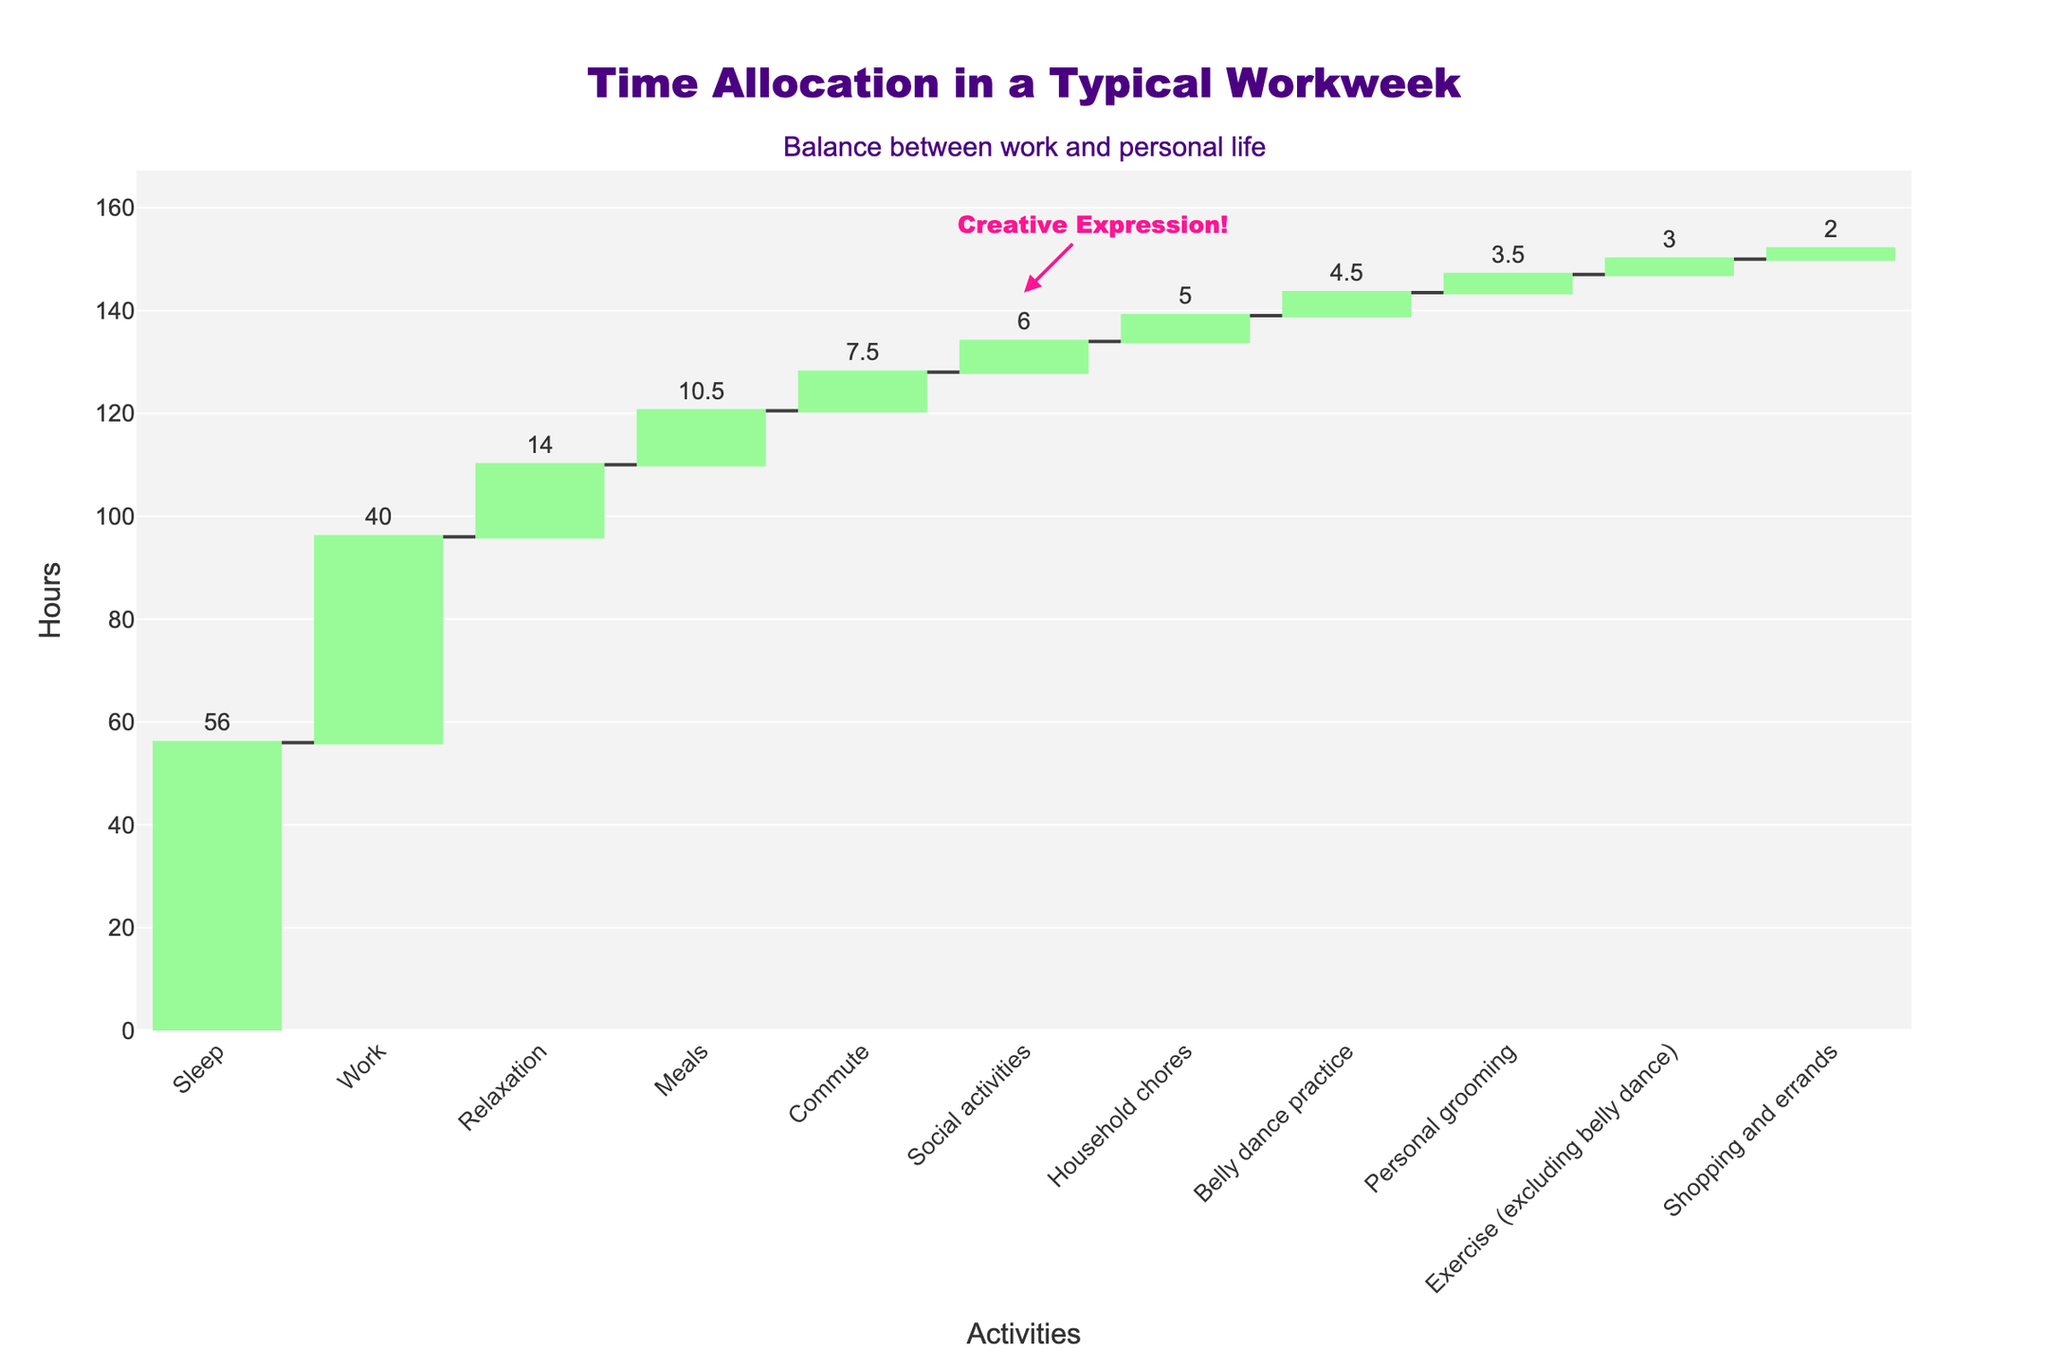What is the total number of hours accounted for in the chart? To find the total number of hours, sum all the individual hours for each activity provided in the chart. The activities are: Work (40), Sleep (56), Commute (7.5), Meals (10.5), Household chores (5), Belly dance practice (4.5), Social activities (6), Personal grooming (3.5), Relaxation (14), Exercise (3), Shopping and errands (2). Adding these up: 40 + 56 + 7.5 + 10.5 + 5 + 4.5 + 6 + 3.5 + 14 + 3 + 2 = 152
Answer: 152 Which activity takes up the most time in a typical workweek? Look for the tallest bar in the waterfall chart to identify the activity with the highest number of hours. The bar for "Sleep" is the tallest.
Answer: Sleep How many hours are allocated to personal grooming and belly dance practice combined? Find the hours for each activity: Personal grooming (3.5) and Belly dance practice (4.5). Then add them together: 3.5 + 4.5 = 8
Answer: 8 Which activity takes up less time: Shopping and errands or Household chores? Compare the heights of the bars for "Shopping and errands" (2 hours) and "Household chores" (5 hours). Shopping and errands have fewer hours.
Answer: Shopping and errands Is the time spent on social activities more than the time spent on commuting? Compare the heights of the bars for "Social activities" (6 hours) and "Commute" (7.5 hours). Social activities take fewer hours than commuting.
Answer: No What percentage of the total time is spent on relaxation? First, find the total hours (152). Then, divide the hours for relaxation by the total hours and multiply by 100 to get the percentage: (14 / 152) * 100 ≈ 9.21%
Answer: 9.21% How many hours per week are dedicated to physical activities, including both exercise and belly dance practice? Identify the hours for each: Exercise excluding belly dance (3) and Belly dance practice (4.5). Add them together: 3 + 4.5 = 7.5
Answer: 7.5 Does Belly dance practice account for more or less hours than meals? Compare the heights of the bars for "Belly dance practice" (4.5 hours) and "Meals" (10.5 hours). Belly dance practice takes fewer hours than meals.
Answer: Less What's the difference in hours between the time spent on work and on relaxation? Subtract the hours spent on relaxation (14) from the hours spent on work (40): 40 - 14 = 26
Answer: 26 What is the combined time spent on meals and household chores? Identify the hours for each: Meals (10.5) and Household chores (5). Add them together: 10.5 + 5 = 15.5
Answer: 15.5 